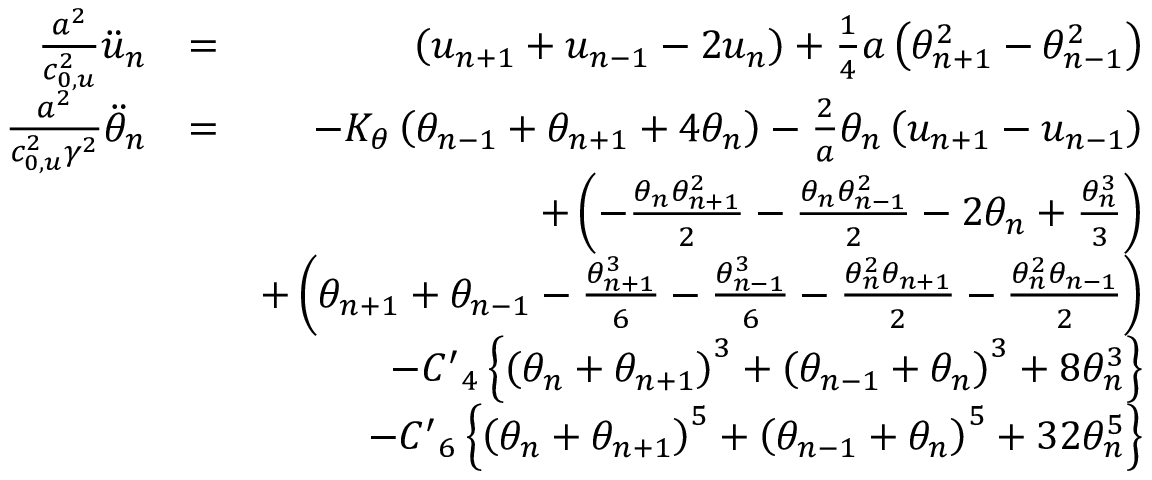Convert formula to latex. <formula><loc_0><loc_0><loc_500><loc_500>\begin{array} { r l r } { \frac { { { a } ^ { 2 } } } { c _ { 0 , u } ^ { 2 } } { { \ddot { u } } _ { n } } } & { = } & { \left ( { { u } _ { n + 1 } } + { { u } _ { n - 1 } } - 2 { { u } _ { n } } \right ) + \frac { 1 } { 4 } a \left ( \theta _ { n + 1 } ^ { 2 } - \theta _ { n - 1 } ^ { 2 } \right ) } \\ { \frac { { { a } ^ { 2 } } } { c _ { 0 , u } ^ { 2 } { { \gamma } ^ { 2 } } } { { { \ddot { \theta } } } _ { n } } } & { = } & { - { { K } _ { \theta } } \left ( { { \theta } _ { n - 1 } } + { { \theta } _ { n + 1 } } + 4 { { \theta } _ { n } } \right ) - \frac { 2 } { a } { { \theta } _ { n } } \left ( { { u } _ { n + 1 } } - { { u } _ { n - 1 } } \right ) } \\ & { + \left ( - \frac { { { \theta } _ { n } } \theta _ { n + 1 } ^ { 2 } } { 2 } - \frac { { { \theta } _ { n } } \theta _ { n - 1 } ^ { 2 } } { 2 } - 2 { { \theta } _ { n } } + \frac { \theta _ { n } ^ { 3 } } { 3 } \right ) } \\ & { + \left ( { { \theta } _ { n + 1 } } + { { \theta } _ { n - 1 } } - \frac { \theta _ { n + 1 } ^ { 3 } } { 6 } - \frac { \theta _ { n - 1 } ^ { 3 } } { 6 } - \frac { \theta _ { n } ^ { 2 } { { \theta } _ { n + 1 } } } { 2 } - \frac { \theta _ { n } ^ { 2 } { { \theta } _ { n - 1 } } } { 2 } \right ) } \\ & { - { { C ^ { \prime } } _ { 4 } } \left \{ { { \left ( { { \theta } _ { n } } + { { \theta } _ { n + 1 } } \right ) } ^ { 3 } } + { { \left ( { { \theta } _ { n - 1 } } + { { \theta } _ { n } } \right ) } ^ { 3 } } + 8 \theta _ { n } ^ { 3 } \right \} } \\ & { - { { C ^ { \prime } } _ { 6 } } \left \{ { { \left ( { { \theta } _ { n } } + { { \theta } _ { n + 1 } } \right ) } ^ { 5 } } + { { \left ( { { \theta } _ { n - 1 } } + { { \theta } _ { n } } \right ) } ^ { 5 } } + 3 2 \theta _ { n } ^ { 5 } \right \} } \end{array}</formula> 